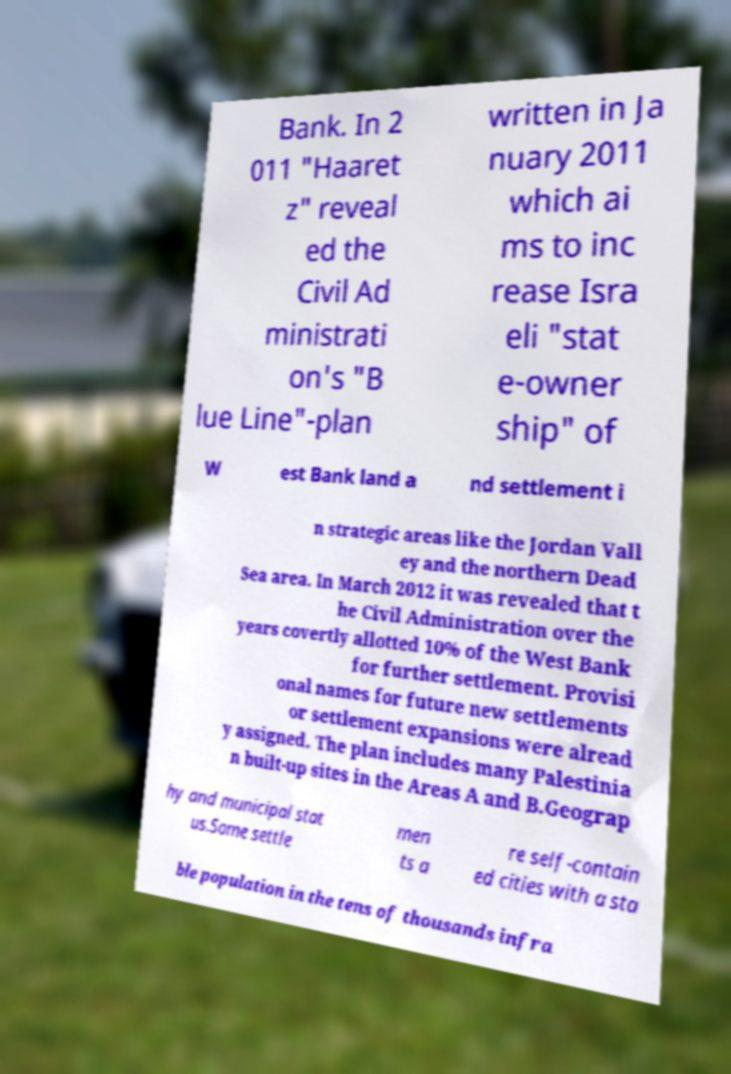Please identify and transcribe the text found in this image. Bank. In 2 011 "Haaret z" reveal ed the Civil Ad ministrati on's "B lue Line"-plan written in Ja nuary 2011 which ai ms to inc rease Isra eli "stat e-owner ship" of W est Bank land a nd settlement i n strategic areas like the Jordan Vall ey and the northern Dead Sea area. In March 2012 it was revealed that t he Civil Administration over the years covertly allotted 10% of the West Bank for further settlement. Provisi onal names for future new settlements or settlement expansions were alread y assigned. The plan includes many Palestinia n built-up sites in the Areas A and B.Geograp hy and municipal stat us.Some settle men ts a re self-contain ed cities with a sta ble population in the tens of thousands infra 